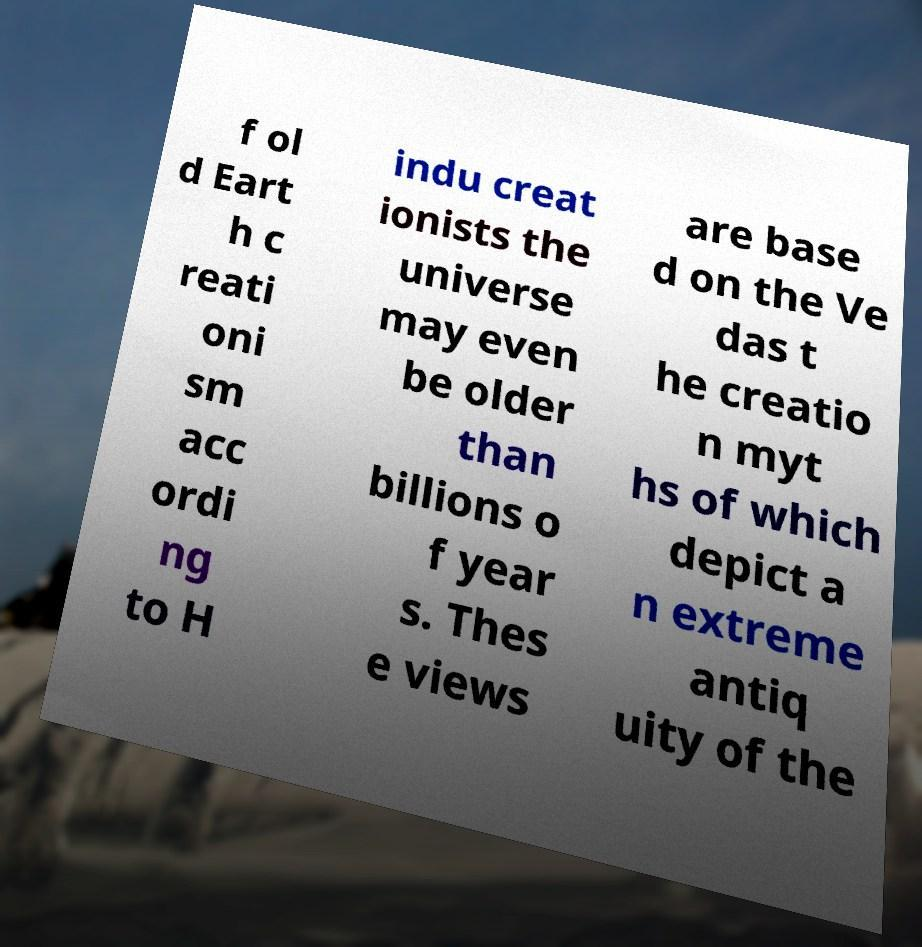Can you accurately transcribe the text from the provided image for me? f ol d Eart h c reati oni sm acc ordi ng to H indu creat ionists the universe may even be older than billions o f year s. Thes e views are base d on the Ve das t he creatio n myt hs of which depict a n extreme antiq uity of the 